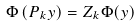<formula> <loc_0><loc_0><loc_500><loc_500>\Phi \left ( P _ { k } y \right ) = Z _ { k } \Phi ( y )</formula> 